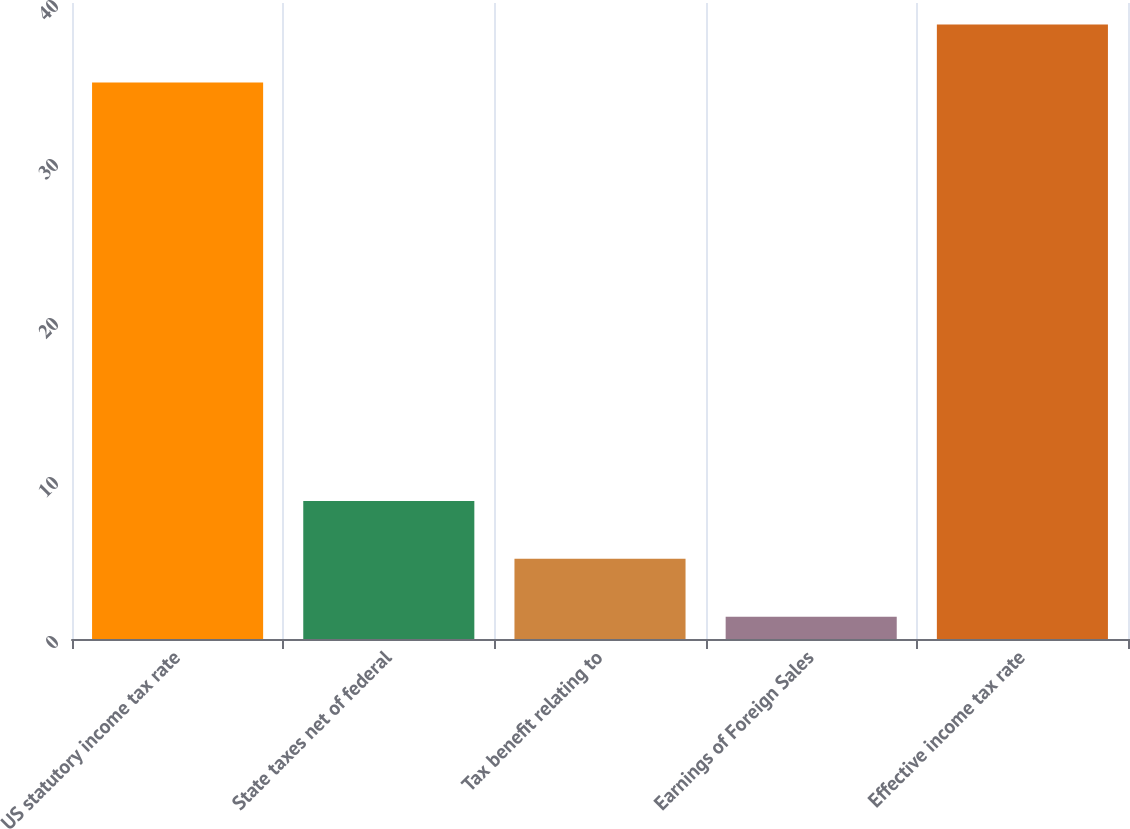Convert chart to OTSL. <chart><loc_0><loc_0><loc_500><loc_500><bar_chart><fcel>US statutory income tax rate<fcel>State taxes net of federal<fcel>Tax benefit relating to<fcel>Earnings of Foreign Sales<fcel>Effective income tax rate<nl><fcel>35<fcel>8.68<fcel>5.04<fcel>1.4<fcel>38.64<nl></chart> 